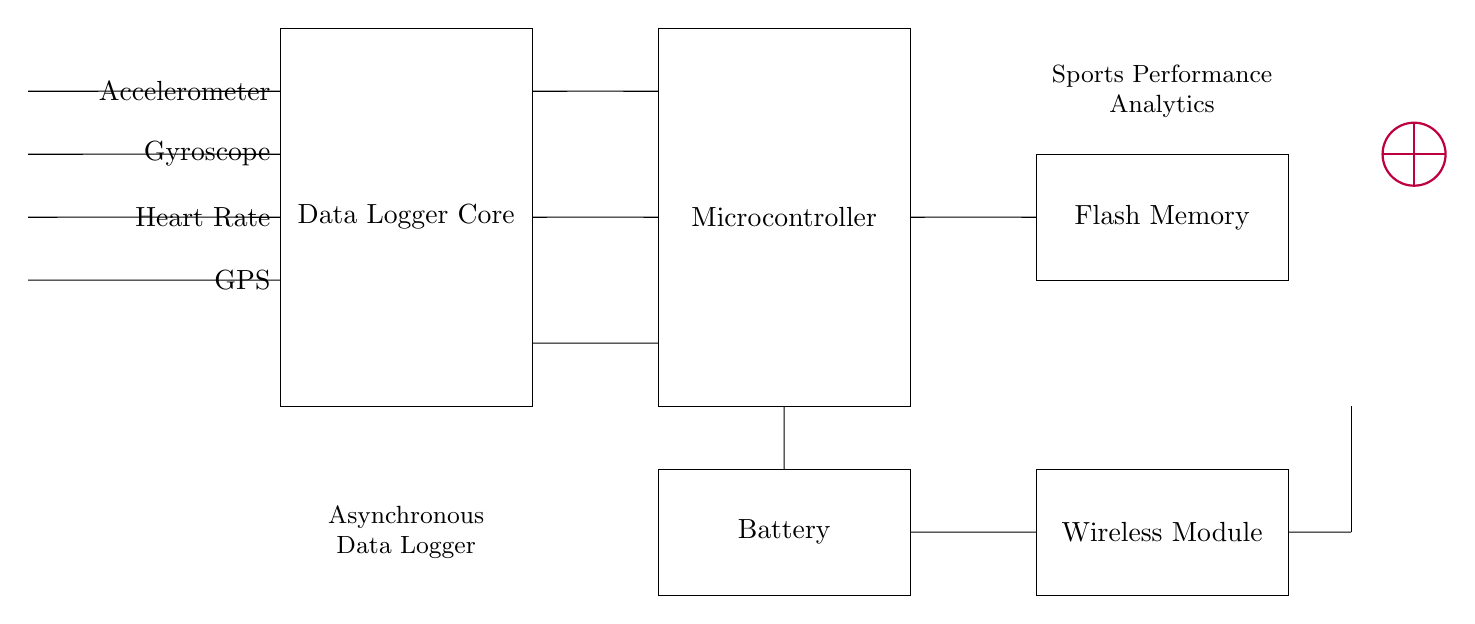What is the main function of the core of the circuit? The core of the circuit is labeled as the Data Logger Core, indicating that its primary function is to log various performance data from the sensors connected to it.
Answer: Data Logger Core How many sensors are there in total? The diagram shows four distinct sensors: Accelerometer, Gyroscope, Heart Rate, and GPS, counting them leads to a total of four sensors connected to the data logger.
Answer: Four What type of memory is used in this circuit? The circuit diagram depicts a rectangle labeled Flash Memory, which typically indicates that non-volatile flash memory is used for data storage in the data logger system.
Answer: Flash Memory Which component collects data, the sensors or the microcontroller? The sensors collect data and send it to the Data Logger Core, which is then processed by the microcontroller for analysis, establishing that the sensors are the initial data collectors in the system.
Answer: Sensors What is the significance of the wireless module in this circuit? The wireless module allows for data transmission from the data logger to external devices, enabling the sharing of performance analytics wirelessly; this enhances the functionality by making data accessible remotely.
Answer: Data transmission How is the power supplied to the circuit? The circuit incorporates a Battery, which supplies power to all connected components, including the data logger and microcontroller, ensuring they operate correctly without needing an external power source.
Answer: Battery What role does the antenna play in this circuit? The antenna is essential for enabling wireless communication of the collected data, facilitating real-time analysis or data sharing to external devices or networks.
Answer: Wireless communication 